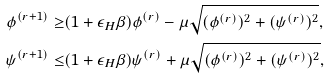Convert formula to latex. <formula><loc_0><loc_0><loc_500><loc_500>\phi ^ { ( r + 1 ) } \geq & ( 1 + \epsilon _ { H } \beta ) \phi ^ { ( r ) } - \mu \sqrt { ( \phi ^ { ( r ) } ) ^ { 2 } + ( \psi ^ { ( r ) } ) ^ { 2 } } , \\ \psi ^ { ( r + 1 ) } \leq & ( 1 + \epsilon _ { H } \beta ) \psi ^ { ( r ) } + \mu \sqrt { ( \phi ^ { ( r ) } ) ^ { 2 } + ( \psi ^ { ( r ) } ) ^ { 2 } } ,</formula> 